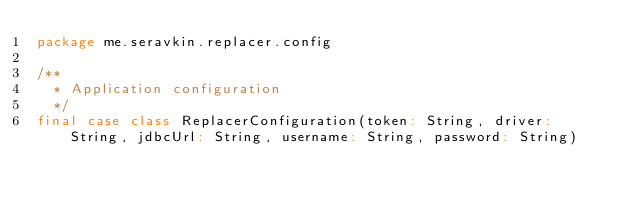Convert code to text. <code><loc_0><loc_0><loc_500><loc_500><_Scala_>package me.seravkin.replacer.config

/**
  * Application configuration
  */
final case class ReplacerConfiguration(token: String, driver: String, jdbcUrl: String, username: String, password: String)</code> 